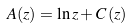Convert formula to latex. <formula><loc_0><loc_0><loc_500><loc_500>A ( z ) = \ln z + C \left ( z \right )</formula> 